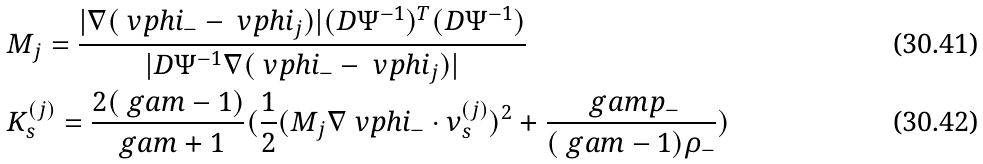<formula> <loc_0><loc_0><loc_500><loc_500>& M _ { j } = \frac { | \nabla ( \ v p h i _ { - } - \ v p h i _ { j } ) | ( D \Psi ^ { - 1 } ) ^ { T } ( D \Psi ^ { - 1 } ) } { | D \Psi ^ { - 1 } \nabla ( \ v p h i _ { - } - \ v p h i _ { j } ) | } \\ & K _ { s } ^ { ( j ) } = \frac { 2 ( \ g a m - 1 ) } { \ g a m + 1 } ( \frac { 1 } { 2 } ( M _ { j } \nabla \ v p h i _ { - } \cdot \nu _ { s } ^ { ( j ) } ) ^ { 2 } + \frac { \ g a m p _ { - } } { ( \ g a m - 1 ) \rho _ { - } } )</formula> 